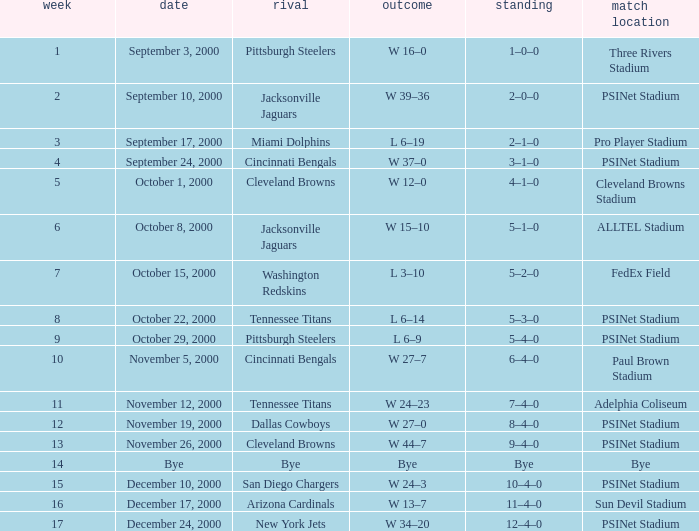What's the record for October 8, 2000 before week 13? 5–1–0. 